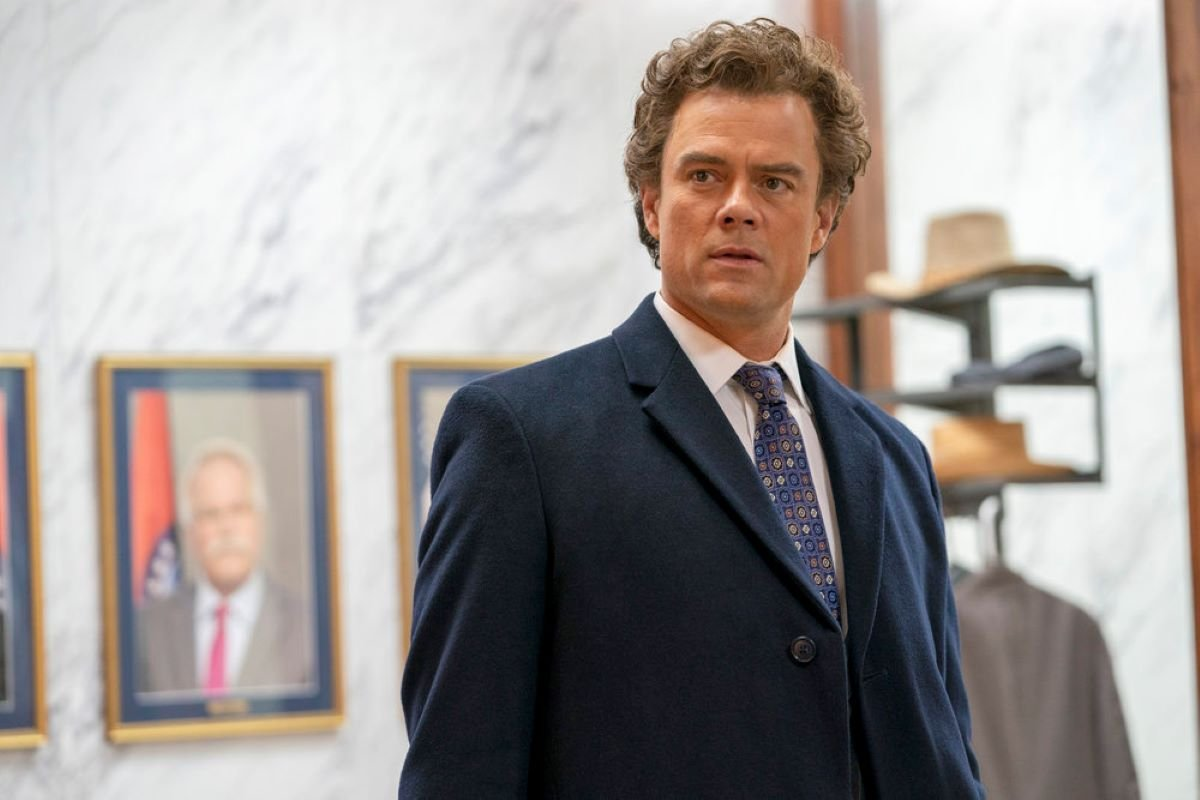What does the suit and tie worn by the man suggest about the occasion or his role? The man's attire, consisting of a tailored dark blue suit and a carefully selected patterned tie, suggests a formal occasion or professional setting. This choice of dress typically indicates a business or ceremonial function, where formal clothing is a sign of respect and professionalism. It may also hint at his role, possibly as an executive, a lawyer, or another position that demands a high degree of professionalism and decorum. Could there be a specific event he is preparing for? Considering his formal dress and the serious, contemplative expression, he could be preparing for an important meeting, presentation, or even a legal proceeding. The surroundings and his preparedness suggest an event that requires not only a professional appearance but also significant preparation and thought, emphasizing the gravity of the forthcoming occasion. 